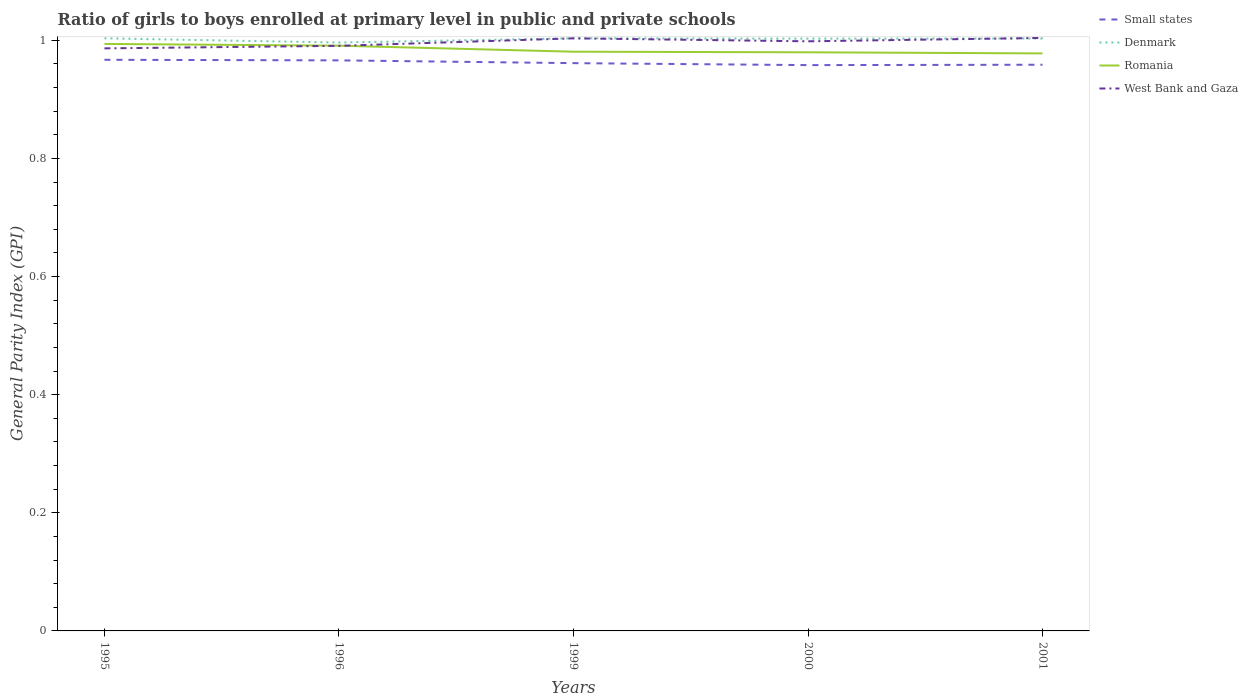How many different coloured lines are there?
Your answer should be very brief. 4. Across all years, what is the maximum general parity index in Denmark?
Ensure brevity in your answer.  1. What is the total general parity index in Romania in the graph?
Your response must be concise. 0.01. What is the difference between the highest and the second highest general parity index in Romania?
Your answer should be very brief. 0.02. How many years are there in the graph?
Your answer should be very brief. 5. Are the values on the major ticks of Y-axis written in scientific E-notation?
Provide a short and direct response. No. Does the graph contain grids?
Your response must be concise. No. Where does the legend appear in the graph?
Ensure brevity in your answer.  Top right. What is the title of the graph?
Your response must be concise. Ratio of girls to boys enrolled at primary level in public and private schools. Does "East Asia (developing only)" appear as one of the legend labels in the graph?
Make the answer very short. No. What is the label or title of the X-axis?
Keep it short and to the point. Years. What is the label or title of the Y-axis?
Give a very brief answer. General Parity Index (GPI). What is the General Parity Index (GPI) in Small states in 1995?
Your response must be concise. 0.97. What is the General Parity Index (GPI) of Denmark in 1995?
Offer a terse response. 1. What is the General Parity Index (GPI) in Romania in 1995?
Your answer should be very brief. 0.99. What is the General Parity Index (GPI) of West Bank and Gaza in 1995?
Your response must be concise. 0.99. What is the General Parity Index (GPI) of Small states in 1996?
Make the answer very short. 0.97. What is the General Parity Index (GPI) in Denmark in 1996?
Give a very brief answer. 1. What is the General Parity Index (GPI) in Romania in 1996?
Provide a short and direct response. 0.99. What is the General Parity Index (GPI) in West Bank and Gaza in 1996?
Your response must be concise. 0.99. What is the General Parity Index (GPI) in Small states in 1999?
Your response must be concise. 0.96. What is the General Parity Index (GPI) of Denmark in 1999?
Ensure brevity in your answer.  1. What is the General Parity Index (GPI) in Romania in 1999?
Keep it short and to the point. 0.98. What is the General Parity Index (GPI) of West Bank and Gaza in 1999?
Offer a very short reply. 1. What is the General Parity Index (GPI) of Small states in 2000?
Your answer should be very brief. 0.96. What is the General Parity Index (GPI) of Denmark in 2000?
Provide a short and direct response. 1. What is the General Parity Index (GPI) in Romania in 2000?
Ensure brevity in your answer.  0.98. What is the General Parity Index (GPI) of West Bank and Gaza in 2000?
Ensure brevity in your answer.  1. What is the General Parity Index (GPI) in Small states in 2001?
Your answer should be compact. 0.96. What is the General Parity Index (GPI) in Denmark in 2001?
Ensure brevity in your answer.  1. What is the General Parity Index (GPI) of Romania in 2001?
Keep it short and to the point. 0.98. What is the General Parity Index (GPI) of West Bank and Gaza in 2001?
Your response must be concise. 1. Across all years, what is the maximum General Parity Index (GPI) of Small states?
Your answer should be very brief. 0.97. Across all years, what is the maximum General Parity Index (GPI) of Denmark?
Ensure brevity in your answer.  1. Across all years, what is the maximum General Parity Index (GPI) of Romania?
Provide a succinct answer. 0.99. Across all years, what is the maximum General Parity Index (GPI) of West Bank and Gaza?
Your response must be concise. 1. Across all years, what is the minimum General Parity Index (GPI) in Small states?
Give a very brief answer. 0.96. Across all years, what is the minimum General Parity Index (GPI) in Denmark?
Keep it short and to the point. 1. Across all years, what is the minimum General Parity Index (GPI) of Romania?
Ensure brevity in your answer.  0.98. Across all years, what is the minimum General Parity Index (GPI) in West Bank and Gaza?
Your answer should be compact. 0.99. What is the total General Parity Index (GPI) of Small states in the graph?
Your answer should be very brief. 4.81. What is the total General Parity Index (GPI) in Denmark in the graph?
Keep it short and to the point. 5.01. What is the total General Parity Index (GPI) in Romania in the graph?
Make the answer very short. 4.92. What is the total General Parity Index (GPI) in West Bank and Gaza in the graph?
Make the answer very short. 4.98. What is the difference between the General Parity Index (GPI) of Denmark in 1995 and that in 1996?
Offer a very short reply. 0.01. What is the difference between the General Parity Index (GPI) in Romania in 1995 and that in 1996?
Provide a short and direct response. 0. What is the difference between the General Parity Index (GPI) in West Bank and Gaza in 1995 and that in 1996?
Provide a short and direct response. -0. What is the difference between the General Parity Index (GPI) of Small states in 1995 and that in 1999?
Make the answer very short. 0.01. What is the difference between the General Parity Index (GPI) of Denmark in 1995 and that in 1999?
Ensure brevity in your answer.  -0. What is the difference between the General Parity Index (GPI) of Romania in 1995 and that in 1999?
Give a very brief answer. 0.01. What is the difference between the General Parity Index (GPI) of West Bank and Gaza in 1995 and that in 1999?
Your answer should be compact. -0.02. What is the difference between the General Parity Index (GPI) in Small states in 1995 and that in 2000?
Make the answer very short. 0.01. What is the difference between the General Parity Index (GPI) of Denmark in 1995 and that in 2000?
Offer a terse response. 0. What is the difference between the General Parity Index (GPI) in Romania in 1995 and that in 2000?
Your response must be concise. 0.01. What is the difference between the General Parity Index (GPI) of West Bank and Gaza in 1995 and that in 2000?
Keep it short and to the point. -0.01. What is the difference between the General Parity Index (GPI) in Small states in 1995 and that in 2001?
Your answer should be compact. 0.01. What is the difference between the General Parity Index (GPI) in Romania in 1995 and that in 2001?
Provide a short and direct response. 0.02. What is the difference between the General Parity Index (GPI) of West Bank and Gaza in 1995 and that in 2001?
Keep it short and to the point. -0.02. What is the difference between the General Parity Index (GPI) in Small states in 1996 and that in 1999?
Provide a succinct answer. 0. What is the difference between the General Parity Index (GPI) of Denmark in 1996 and that in 1999?
Make the answer very short. -0.01. What is the difference between the General Parity Index (GPI) of Romania in 1996 and that in 1999?
Offer a very short reply. 0.01. What is the difference between the General Parity Index (GPI) in West Bank and Gaza in 1996 and that in 1999?
Ensure brevity in your answer.  -0.01. What is the difference between the General Parity Index (GPI) of Small states in 1996 and that in 2000?
Provide a short and direct response. 0.01. What is the difference between the General Parity Index (GPI) of Denmark in 1996 and that in 2000?
Make the answer very short. -0.01. What is the difference between the General Parity Index (GPI) of Romania in 1996 and that in 2000?
Offer a terse response. 0.01. What is the difference between the General Parity Index (GPI) of West Bank and Gaza in 1996 and that in 2000?
Keep it short and to the point. -0.01. What is the difference between the General Parity Index (GPI) in Small states in 1996 and that in 2001?
Your answer should be compact. 0.01. What is the difference between the General Parity Index (GPI) of Denmark in 1996 and that in 2001?
Keep it short and to the point. -0.01. What is the difference between the General Parity Index (GPI) of Romania in 1996 and that in 2001?
Provide a short and direct response. 0.01. What is the difference between the General Parity Index (GPI) of West Bank and Gaza in 1996 and that in 2001?
Ensure brevity in your answer.  -0.01. What is the difference between the General Parity Index (GPI) in Small states in 1999 and that in 2000?
Your response must be concise. 0. What is the difference between the General Parity Index (GPI) in Denmark in 1999 and that in 2000?
Offer a very short reply. 0. What is the difference between the General Parity Index (GPI) of West Bank and Gaza in 1999 and that in 2000?
Keep it short and to the point. 0.01. What is the difference between the General Parity Index (GPI) in Small states in 1999 and that in 2001?
Ensure brevity in your answer.  0. What is the difference between the General Parity Index (GPI) of Romania in 1999 and that in 2001?
Provide a short and direct response. 0. What is the difference between the General Parity Index (GPI) of West Bank and Gaza in 1999 and that in 2001?
Ensure brevity in your answer.  -0. What is the difference between the General Parity Index (GPI) in Small states in 2000 and that in 2001?
Offer a very short reply. -0. What is the difference between the General Parity Index (GPI) of Denmark in 2000 and that in 2001?
Your answer should be very brief. -0. What is the difference between the General Parity Index (GPI) in Romania in 2000 and that in 2001?
Your answer should be very brief. 0. What is the difference between the General Parity Index (GPI) of West Bank and Gaza in 2000 and that in 2001?
Make the answer very short. -0.01. What is the difference between the General Parity Index (GPI) of Small states in 1995 and the General Parity Index (GPI) of Denmark in 1996?
Your answer should be compact. -0.03. What is the difference between the General Parity Index (GPI) in Small states in 1995 and the General Parity Index (GPI) in Romania in 1996?
Ensure brevity in your answer.  -0.02. What is the difference between the General Parity Index (GPI) of Small states in 1995 and the General Parity Index (GPI) of West Bank and Gaza in 1996?
Give a very brief answer. -0.02. What is the difference between the General Parity Index (GPI) in Denmark in 1995 and the General Parity Index (GPI) in Romania in 1996?
Your answer should be compact. 0.01. What is the difference between the General Parity Index (GPI) of Denmark in 1995 and the General Parity Index (GPI) of West Bank and Gaza in 1996?
Offer a terse response. 0.01. What is the difference between the General Parity Index (GPI) of Romania in 1995 and the General Parity Index (GPI) of West Bank and Gaza in 1996?
Make the answer very short. 0. What is the difference between the General Parity Index (GPI) of Small states in 1995 and the General Parity Index (GPI) of Denmark in 1999?
Your response must be concise. -0.04. What is the difference between the General Parity Index (GPI) in Small states in 1995 and the General Parity Index (GPI) in Romania in 1999?
Ensure brevity in your answer.  -0.01. What is the difference between the General Parity Index (GPI) in Small states in 1995 and the General Parity Index (GPI) in West Bank and Gaza in 1999?
Your response must be concise. -0.04. What is the difference between the General Parity Index (GPI) of Denmark in 1995 and the General Parity Index (GPI) of Romania in 1999?
Make the answer very short. 0.02. What is the difference between the General Parity Index (GPI) of Denmark in 1995 and the General Parity Index (GPI) of West Bank and Gaza in 1999?
Your answer should be very brief. -0. What is the difference between the General Parity Index (GPI) in Romania in 1995 and the General Parity Index (GPI) in West Bank and Gaza in 1999?
Your response must be concise. -0.01. What is the difference between the General Parity Index (GPI) of Small states in 1995 and the General Parity Index (GPI) of Denmark in 2000?
Give a very brief answer. -0.04. What is the difference between the General Parity Index (GPI) of Small states in 1995 and the General Parity Index (GPI) of Romania in 2000?
Make the answer very short. -0.01. What is the difference between the General Parity Index (GPI) of Small states in 1995 and the General Parity Index (GPI) of West Bank and Gaza in 2000?
Offer a terse response. -0.03. What is the difference between the General Parity Index (GPI) in Denmark in 1995 and the General Parity Index (GPI) in Romania in 2000?
Keep it short and to the point. 0.02. What is the difference between the General Parity Index (GPI) in Denmark in 1995 and the General Parity Index (GPI) in West Bank and Gaza in 2000?
Your response must be concise. 0.01. What is the difference between the General Parity Index (GPI) of Romania in 1995 and the General Parity Index (GPI) of West Bank and Gaza in 2000?
Give a very brief answer. -0. What is the difference between the General Parity Index (GPI) of Small states in 1995 and the General Parity Index (GPI) of Denmark in 2001?
Make the answer very short. -0.04. What is the difference between the General Parity Index (GPI) of Small states in 1995 and the General Parity Index (GPI) of Romania in 2001?
Your answer should be very brief. -0.01. What is the difference between the General Parity Index (GPI) of Small states in 1995 and the General Parity Index (GPI) of West Bank and Gaza in 2001?
Give a very brief answer. -0.04. What is the difference between the General Parity Index (GPI) of Denmark in 1995 and the General Parity Index (GPI) of Romania in 2001?
Make the answer very short. 0.03. What is the difference between the General Parity Index (GPI) in Denmark in 1995 and the General Parity Index (GPI) in West Bank and Gaza in 2001?
Ensure brevity in your answer.  -0. What is the difference between the General Parity Index (GPI) in Romania in 1995 and the General Parity Index (GPI) in West Bank and Gaza in 2001?
Keep it short and to the point. -0.01. What is the difference between the General Parity Index (GPI) in Small states in 1996 and the General Parity Index (GPI) in Denmark in 1999?
Your answer should be compact. -0.04. What is the difference between the General Parity Index (GPI) in Small states in 1996 and the General Parity Index (GPI) in Romania in 1999?
Your response must be concise. -0.01. What is the difference between the General Parity Index (GPI) of Small states in 1996 and the General Parity Index (GPI) of West Bank and Gaza in 1999?
Offer a very short reply. -0.04. What is the difference between the General Parity Index (GPI) in Denmark in 1996 and the General Parity Index (GPI) in Romania in 1999?
Keep it short and to the point. 0.02. What is the difference between the General Parity Index (GPI) of Denmark in 1996 and the General Parity Index (GPI) of West Bank and Gaza in 1999?
Make the answer very short. -0.01. What is the difference between the General Parity Index (GPI) of Romania in 1996 and the General Parity Index (GPI) of West Bank and Gaza in 1999?
Your answer should be very brief. -0.01. What is the difference between the General Parity Index (GPI) of Small states in 1996 and the General Parity Index (GPI) of Denmark in 2000?
Give a very brief answer. -0.04. What is the difference between the General Parity Index (GPI) of Small states in 1996 and the General Parity Index (GPI) of Romania in 2000?
Your response must be concise. -0.01. What is the difference between the General Parity Index (GPI) of Small states in 1996 and the General Parity Index (GPI) of West Bank and Gaza in 2000?
Ensure brevity in your answer.  -0.03. What is the difference between the General Parity Index (GPI) of Denmark in 1996 and the General Parity Index (GPI) of Romania in 2000?
Give a very brief answer. 0.02. What is the difference between the General Parity Index (GPI) of Denmark in 1996 and the General Parity Index (GPI) of West Bank and Gaza in 2000?
Make the answer very short. -0. What is the difference between the General Parity Index (GPI) in Romania in 1996 and the General Parity Index (GPI) in West Bank and Gaza in 2000?
Your response must be concise. -0.01. What is the difference between the General Parity Index (GPI) of Small states in 1996 and the General Parity Index (GPI) of Denmark in 2001?
Provide a succinct answer. -0.04. What is the difference between the General Parity Index (GPI) in Small states in 1996 and the General Parity Index (GPI) in Romania in 2001?
Offer a very short reply. -0.01. What is the difference between the General Parity Index (GPI) of Small states in 1996 and the General Parity Index (GPI) of West Bank and Gaza in 2001?
Your answer should be very brief. -0.04. What is the difference between the General Parity Index (GPI) in Denmark in 1996 and the General Parity Index (GPI) in Romania in 2001?
Provide a short and direct response. 0.02. What is the difference between the General Parity Index (GPI) of Denmark in 1996 and the General Parity Index (GPI) of West Bank and Gaza in 2001?
Your answer should be very brief. -0.01. What is the difference between the General Parity Index (GPI) in Romania in 1996 and the General Parity Index (GPI) in West Bank and Gaza in 2001?
Give a very brief answer. -0.01. What is the difference between the General Parity Index (GPI) of Small states in 1999 and the General Parity Index (GPI) of Denmark in 2000?
Ensure brevity in your answer.  -0.04. What is the difference between the General Parity Index (GPI) of Small states in 1999 and the General Parity Index (GPI) of Romania in 2000?
Ensure brevity in your answer.  -0.02. What is the difference between the General Parity Index (GPI) of Small states in 1999 and the General Parity Index (GPI) of West Bank and Gaza in 2000?
Ensure brevity in your answer.  -0.04. What is the difference between the General Parity Index (GPI) of Denmark in 1999 and the General Parity Index (GPI) of Romania in 2000?
Provide a succinct answer. 0.02. What is the difference between the General Parity Index (GPI) in Denmark in 1999 and the General Parity Index (GPI) in West Bank and Gaza in 2000?
Ensure brevity in your answer.  0.01. What is the difference between the General Parity Index (GPI) in Romania in 1999 and the General Parity Index (GPI) in West Bank and Gaza in 2000?
Give a very brief answer. -0.02. What is the difference between the General Parity Index (GPI) in Small states in 1999 and the General Parity Index (GPI) in Denmark in 2001?
Offer a very short reply. -0.04. What is the difference between the General Parity Index (GPI) in Small states in 1999 and the General Parity Index (GPI) in Romania in 2001?
Make the answer very short. -0.02. What is the difference between the General Parity Index (GPI) in Small states in 1999 and the General Parity Index (GPI) in West Bank and Gaza in 2001?
Your answer should be compact. -0.04. What is the difference between the General Parity Index (GPI) of Denmark in 1999 and the General Parity Index (GPI) of Romania in 2001?
Provide a short and direct response. 0.03. What is the difference between the General Parity Index (GPI) of Denmark in 1999 and the General Parity Index (GPI) of West Bank and Gaza in 2001?
Offer a terse response. -0. What is the difference between the General Parity Index (GPI) of Romania in 1999 and the General Parity Index (GPI) of West Bank and Gaza in 2001?
Your answer should be very brief. -0.02. What is the difference between the General Parity Index (GPI) in Small states in 2000 and the General Parity Index (GPI) in Denmark in 2001?
Provide a short and direct response. -0.05. What is the difference between the General Parity Index (GPI) in Small states in 2000 and the General Parity Index (GPI) in Romania in 2001?
Offer a terse response. -0.02. What is the difference between the General Parity Index (GPI) of Small states in 2000 and the General Parity Index (GPI) of West Bank and Gaza in 2001?
Offer a terse response. -0.05. What is the difference between the General Parity Index (GPI) of Denmark in 2000 and the General Parity Index (GPI) of Romania in 2001?
Your answer should be very brief. 0.03. What is the difference between the General Parity Index (GPI) of Denmark in 2000 and the General Parity Index (GPI) of West Bank and Gaza in 2001?
Offer a very short reply. -0. What is the difference between the General Parity Index (GPI) of Romania in 2000 and the General Parity Index (GPI) of West Bank and Gaza in 2001?
Offer a very short reply. -0.02. What is the average General Parity Index (GPI) in Small states per year?
Offer a terse response. 0.96. What is the average General Parity Index (GPI) in Romania per year?
Ensure brevity in your answer.  0.98. What is the average General Parity Index (GPI) in West Bank and Gaza per year?
Give a very brief answer. 1. In the year 1995, what is the difference between the General Parity Index (GPI) in Small states and General Parity Index (GPI) in Denmark?
Keep it short and to the point. -0.04. In the year 1995, what is the difference between the General Parity Index (GPI) of Small states and General Parity Index (GPI) of Romania?
Your answer should be very brief. -0.03. In the year 1995, what is the difference between the General Parity Index (GPI) of Small states and General Parity Index (GPI) of West Bank and Gaza?
Your answer should be compact. -0.02. In the year 1995, what is the difference between the General Parity Index (GPI) in Denmark and General Parity Index (GPI) in Romania?
Make the answer very short. 0.01. In the year 1995, what is the difference between the General Parity Index (GPI) in Denmark and General Parity Index (GPI) in West Bank and Gaza?
Ensure brevity in your answer.  0.02. In the year 1995, what is the difference between the General Parity Index (GPI) in Romania and General Parity Index (GPI) in West Bank and Gaza?
Provide a short and direct response. 0.01. In the year 1996, what is the difference between the General Parity Index (GPI) in Small states and General Parity Index (GPI) in Denmark?
Provide a short and direct response. -0.03. In the year 1996, what is the difference between the General Parity Index (GPI) in Small states and General Parity Index (GPI) in Romania?
Your answer should be compact. -0.02. In the year 1996, what is the difference between the General Parity Index (GPI) of Small states and General Parity Index (GPI) of West Bank and Gaza?
Offer a terse response. -0.02. In the year 1996, what is the difference between the General Parity Index (GPI) in Denmark and General Parity Index (GPI) in Romania?
Your answer should be very brief. 0.01. In the year 1996, what is the difference between the General Parity Index (GPI) in Denmark and General Parity Index (GPI) in West Bank and Gaza?
Ensure brevity in your answer.  0.01. In the year 1999, what is the difference between the General Parity Index (GPI) in Small states and General Parity Index (GPI) in Denmark?
Your answer should be compact. -0.04. In the year 1999, what is the difference between the General Parity Index (GPI) in Small states and General Parity Index (GPI) in Romania?
Keep it short and to the point. -0.02. In the year 1999, what is the difference between the General Parity Index (GPI) of Small states and General Parity Index (GPI) of West Bank and Gaza?
Give a very brief answer. -0.04. In the year 1999, what is the difference between the General Parity Index (GPI) of Denmark and General Parity Index (GPI) of Romania?
Keep it short and to the point. 0.02. In the year 1999, what is the difference between the General Parity Index (GPI) in Denmark and General Parity Index (GPI) in West Bank and Gaza?
Provide a succinct answer. 0. In the year 1999, what is the difference between the General Parity Index (GPI) in Romania and General Parity Index (GPI) in West Bank and Gaza?
Your response must be concise. -0.02. In the year 2000, what is the difference between the General Parity Index (GPI) of Small states and General Parity Index (GPI) of Denmark?
Make the answer very short. -0.04. In the year 2000, what is the difference between the General Parity Index (GPI) in Small states and General Parity Index (GPI) in Romania?
Provide a succinct answer. -0.02. In the year 2000, what is the difference between the General Parity Index (GPI) in Small states and General Parity Index (GPI) in West Bank and Gaza?
Your response must be concise. -0.04. In the year 2000, what is the difference between the General Parity Index (GPI) in Denmark and General Parity Index (GPI) in Romania?
Provide a succinct answer. 0.02. In the year 2000, what is the difference between the General Parity Index (GPI) in Denmark and General Parity Index (GPI) in West Bank and Gaza?
Make the answer very short. 0. In the year 2000, what is the difference between the General Parity Index (GPI) in Romania and General Parity Index (GPI) in West Bank and Gaza?
Offer a terse response. -0.02. In the year 2001, what is the difference between the General Parity Index (GPI) of Small states and General Parity Index (GPI) of Denmark?
Keep it short and to the point. -0.04. In the year 2001, what is the difference between the General Parity Index (GPI) of Small states and General Parity Index (GPI) of Romania?
Your answer should be very brief. -0.02. In the year 2001, what is the difference between the General Parity Index (GPI) of Small states and General Parity Index (GPI) of West Bank and Gaza?
Provide a succinct answer. -0.05. In the year 2001, what is the difference between the General Parity Index (GPI) in Denmark and General Parity Index (GPI) in Romania?
Offer a terse response. 0.03. In the year 2001, what is the difference between the General Parity Index (GPI) of Denmark and General Parity Index (GPI) of West Bank and Gaza?
Give a very brief answer. -0. In the year 2001, what is the difference between the General Parity Index (GPI) of Romania and General Parity Index (GPI) of West Bank and Gaza?
Your answer should be very brief. -0.03. What is the ratio of the General Parity Index (GPI) in Small states in 1995 to that in 1996?
Provide a succinct answer. 1. What is the ratio of the General Parity Index (GPI) of Denmark in 1995 to that in 1996?
Provide a succinct answer. 1.01. What is the ratio of the General Parity Index (GPI) in Small states in 1995 to that in 1999?
Make the answer very short. 1.01. What is the ratio of the General Parity Index (GPI) of Romania in 1995 to that in 1999?
Your response must be concise. 1.01. What is the ratio of the General Parity Index (GPI) of West Bank and Gaza in 1995 to that in 1999?
Offer a very short reply. 0.98. What is the ratio of the General Parity Index (GPI) of Small states in 1995 to that in 2000?
Your response must be concise. 1.01. What is the ratio of the General Parity Index (GPI) of Denmark in 1995 to that in 2000?
Provide a short and direct response. 1. What is the ratio of the General Parity Index (GPI) in Romania in 1995 to that in 2000?
Provide a short and direct response. 1.01. What is the ratio of the General Parity Index (GPI) in Small states in 1995 to that in 2001?
Provide a short and direct response. 1.01. What is the ratio of the General Parity Index (GPI) of Romania in 1995 to that in 2001?
Ensure brevity in your answer.  1.02. What is the ratio of the General Parity Index (GPI) in West Bank and Gaza in 1995 to that in 2001?
Give a very brief answer. 0.98. What is the ratio of the General Parity Index (GPI) in Romania in 1996 to that in 1999?
Your response must be concise. 1.01. What is the ratio of the General Parity Index (GPI) in West Bank and Gaza in 1996 to that in 1999?
Offer a very short reply. 0.99. What is the ratio of the General Parity Index (GPI) of Small states in 1996 to that in 2000?
Give a very brief answer. 1.01. What is the ratio of the General Parity Index (GPI) of Denmark in 1996 to that in 2000?
Provide a short and direct response. 0.99. What is the ratio of the General Parity Index (GPI) of Romania in 1996 to that in 2000?
Make the answer very short. 1.01. What is the ratio of the General Parity Index (GPI) in West Bank and Gaza in 1996 to that in 2000?
Offer a terse response. 0.99. What is the ratio of the General Parity Index (GPI) in Small states in 1996 to that in 2001?
Offer a terse response. 1.01. What is the ratio of the General Parity Index (GPI) in Denmark in 1996 to that in 2001?
Your answer should be compact. 0.99. What is the ratio of the General Parity Index (GPI) of Romania in 1996 to that in 2001?
Give a very brief answer. 1.01. What is the ratio of the General Parity Index (GPI) in West Bank and Gaza in 1996 to that in 2001?
Ensure brevity in your answer.  0.99. What is the ratio of the General Parity Index (GPI) of Small states in 1999 to that in 2000?
Provide a succinct answer. 1. What is the ratio of the General Parity Index (GPI) of Denmark in 1999 to that in 2000?
Your response must be concise. 1. What is the ratio of the General Parity Index (GPI) in West Bank and Gaza in 1999 to that in 2000?
Your answer should be compact. 1. What is the ratio of the General Parity Index (GPI) of West Bank and Gaza in 1999 to that in 2001?
Make the answer very short. 1. What is the ratio of the General Parity Index (GPI) in Small states in 2000 to that in 2001?
Provide a succinct answer. 1. What is the ratio of the General Parity Index (GPI) of Denmark in 2000 to that in 2001?
Keep it short and to the point. 1. What is the ratio of the General Parity Index (GPI) of Romania in 2000 to that in 2001?
Your answer should be compact. 1. What is the difference between the highest and the second highest General Parity Index (GPI) in Denmark?
Your answer should be very brief. 0. What is the difference between the highest and the second highest General Parity Index (GPI) in Romania?
Provide a succinct answer. 0. What is the difference between the highest and the second highest General Parity Index (GPI) in West Bank and Gaza?
Your answer should be very brief. 0. What is the difference between the highest and the lowest General Parity Index (GPI) of Small states?
Give a very brief answer. 0.01. What is the difference between the highest and the lowest General Parity Index (GPI) in Denmark?
Offer a terse response. 0.01. What is the difference between the highest and the lowest General Parity Index (GPI) of Romania?
Your response must be concise. 0.02. What is the difference between the highest and the lowest General Parity Index (GPI) in West Bank and Gaza?
Ensure brevity in your answer.  0.02. 